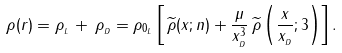Convert formula to latex. <formula><loc_0><loc_0><loc_500><loc_500>\rho ( r ) = \rho _ { _ { L } } \, + \, \rho _ { _ { D } } = \rho _ { 0 _ { L } } \left [ \, \widetilde { \rho } ( x ; n ) + \frac { \mu } { x _ { _ { D } } ^ { 3 } } \, \widetilde { \rho } \left ( \frac { x } { x _ { _ { D } } } ; 3 \right ) \right ] .</formula> 